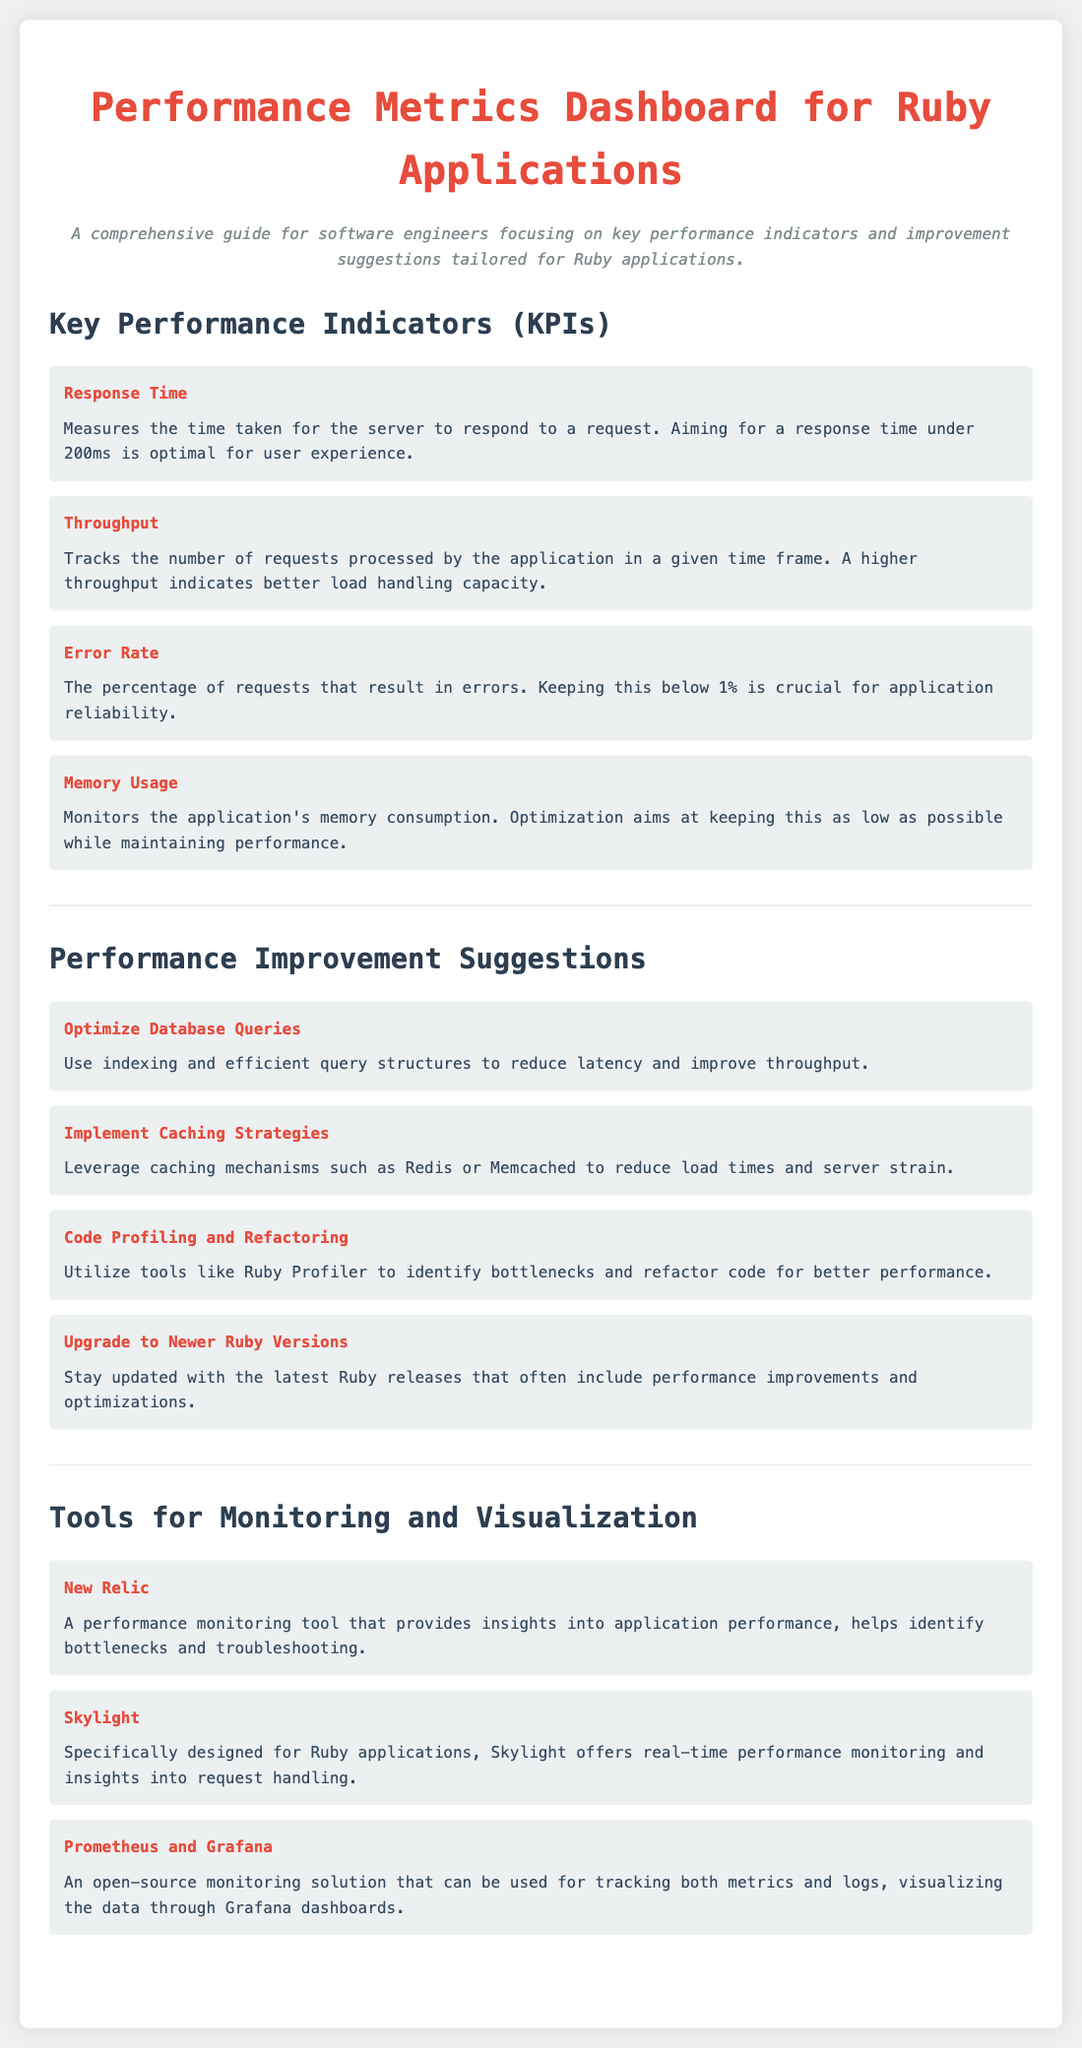What is the ideal response time for a Ruby application? The document states that aiming for a response time under 200ms is optimal for user experience.
Answer: under 200ms What is the maximum acceptable error rate for Ruby applications? The acceptable error rate to maintain application reliability is specified as below 1%.
Answer: below 1% What performance monitoring tool is designed specifically for Ruby applications? The document mentions Skylight as a tool specifically designed for Ruby applications.
Answer: Skylight What is suggested to reduce latency and improve throughput? The improvement suggestion states to use indexing and efficient query structures.
Answer: Optimize Database Queries How many key performance indicators are listed in the document? There are four Key Performance Indicators mentioned under the KPIs section of the document.
Answer: Four What is one tool mentioned for tracking metrics and logs? The document lists Prometheus and Grafana as a monitoring solution for tracking metrics and logs.
Answer: Prometheus and Grafana Which suggestion relates to improving code quality? The document recommends code profiling and refactoring as an improvement suggestion.
Answer: Code Profiling and Refactoring What is the color of the titles for the performance improvement suggestions? The document indicates that the titles are colored in #e74c3c, which is a shade of red.
Answer: #e74c3c 